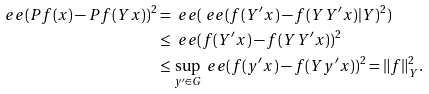Convert formula to latex. <formula><loc_0><loc_0><loc_500><loc_500>\ e e ( P f ( x ) - P f ( Y x ) ) ^ { 2 } & = \ e e ( \ e e ( f ( Y ^ { \prime } x ) - f ( Y Y ^ { \prime } x ) | Y ) ^ { 2 } ) \\ & \leq \ e e ( f ( Y ^ { \prime } x ) - f ( Y Y ^ { \prime } x ) ) ^ { 2 } \\ & \leq \sup _ { y ^ { \prime } \in G } \ e e ( f ( y ^ { \prime } x ) - f ( Y y ^ { \prime } x ) ) ^ { 2 } = \| f \| _ { Y } ^ { 2 } .</formula> 